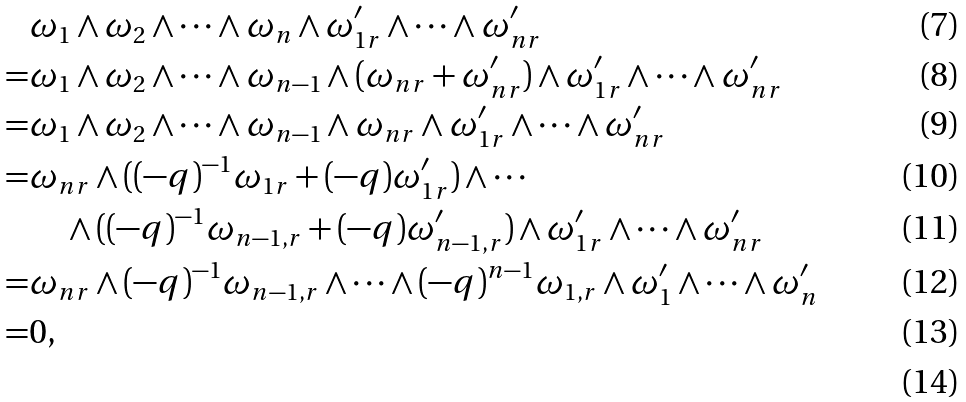Convert formula to latex. <formula><loc_0><loc_0><loc_500><loc_500>& \omega _ { 1 } \wedge \omega _ { 2 } \wedge \cdots \wedge \omega _ { n } \wedge \omega _ { 1 r } ^ { \prime } \wedge \cdots \wedge \omega _ { n r } ^ { \prime } \\ = & \omega _ { 1 } \wedge \omega _ { 2 } \wedge \cdots \wedge \omega _ { n - 1 } \wedge ( \omega _ { n r } + \omega _ { n r } ^ { \prime } ) \wedge \omega _ { 1 r } ^ { \prime } \wedge \cdots \wedge \omega _ { n r } ^ { \prime } \\ = & \omega _ { 1 } \wedge \omega _ { 2 } \wedge \cdots \wedge \omega _ { n - 1 } \wedge \omega _ { n r } \wedge \omega _ { 1 r } ^ { \prime } \wedge \cdots \wedge \omega _ { n r } ^ { \prime } \\ = & \omega _ { n r } \wedge ( ( - q ) ^ { - 1 } \omega _ { 1 r } + ( - q ) \omega _ { 1 r } ^ { \prime } ) \wedge \cdots \\ & \quad \wedge ( ( - q ) ^ { - 1 } \omega _ { n - 1 , r } + ( - q ) \omega _ { n - 1 , r } ^ { \prime } ) \wedge \omega _ { 1 r } ^ { \prime } \wedge \cdots \wedge \omega _ { n r } ^ { \prime } \\ = & \omega _ { n r } \wedge ( - q ) ^ { - 1 } \omega _ { n - 1 , r } \wedge \cdots \wedge ( - q ) ^ { n - 1 } \omega _ { 1 , r } \wedge \omega _ { 1 } ^ { \prime } \wedge \cdots \wedge \omega _ { n } ^ { \prime } \\ = & 0 , \\</formula> 